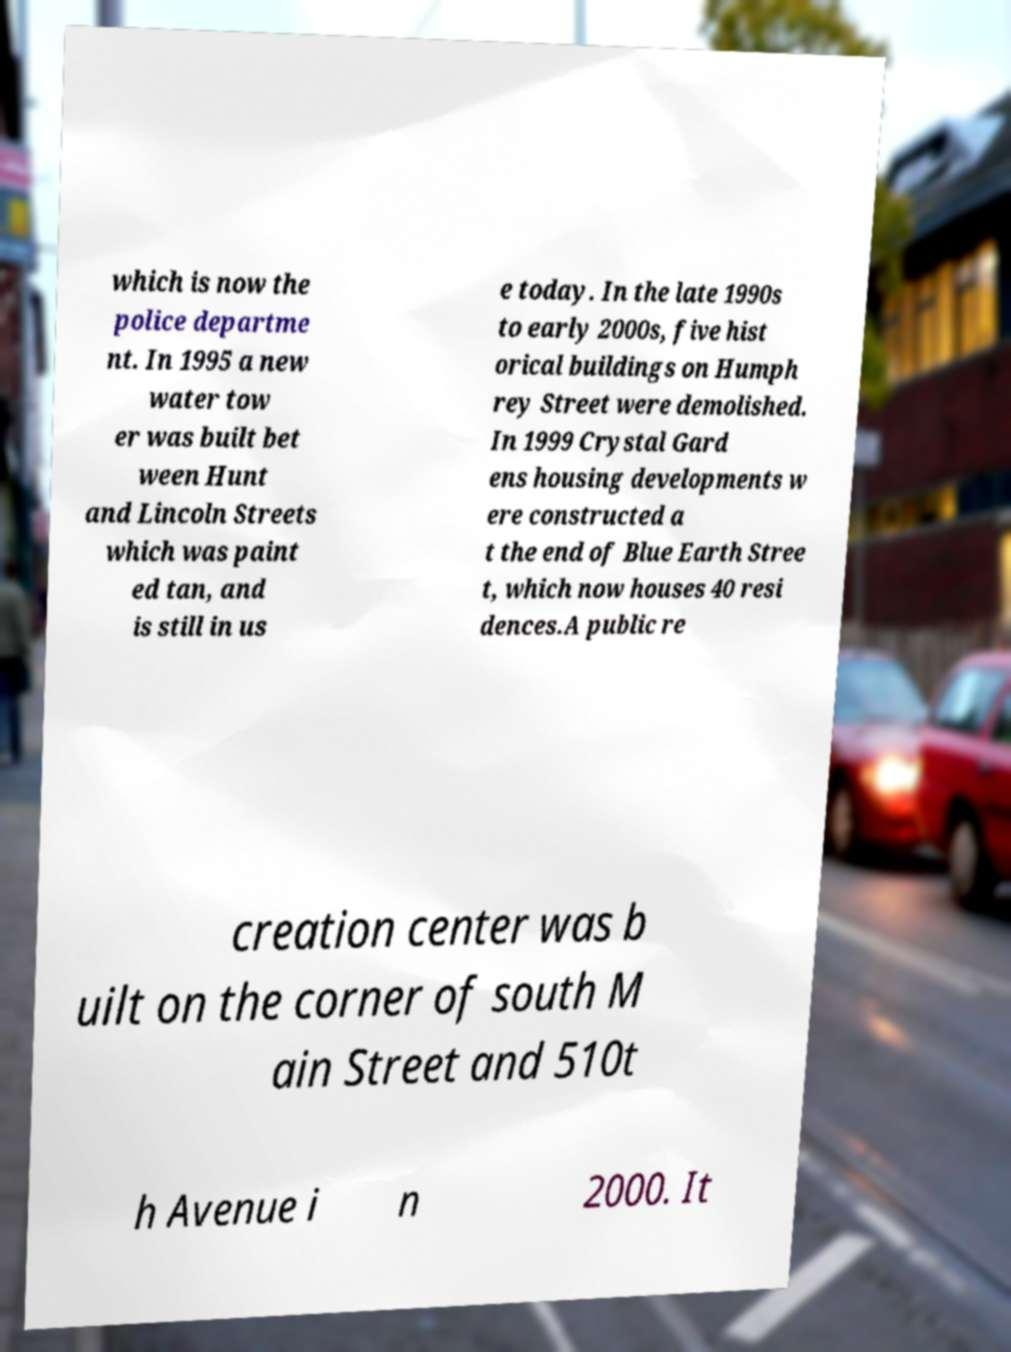Could you assist in decoding the text presented in this image and type it out clearly? which is now the police departme nt. In 1995 a new water tow er was built bet ween Hunt and Lincoln Streets which was paint ed tan, and is still in us e today. In the late 1990s to early 2000s, five hist orical buildings on Humph rey Street were demolished. In 1999 Crystal Gard ens housing developments w ere constructed a t the end of Blue Earth Stree t, which now houses 40 resi dences.A public re creation center was b uilt on the corner of south M ain Street and 510t h Avenue i n 2000. It 